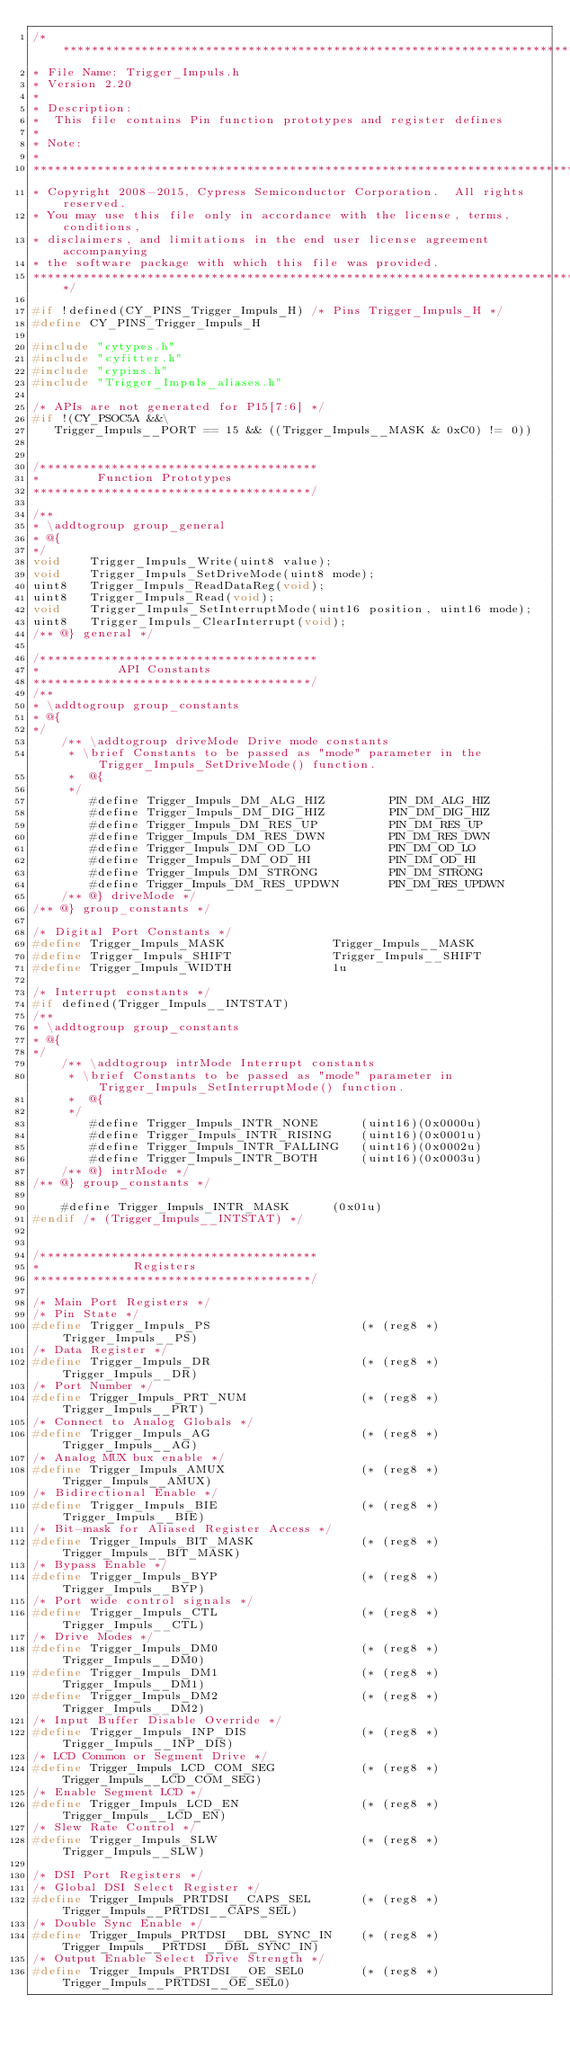<code> <loc_0><loc_0><loc_500><loc_500><_C_>/*******************************************************************************
* File Name: Trigger_Impuls.h  
* Version 2.20
*
* Description:
*  This file contains Pin function prototypes and register defines
*
* Note:
*
********************************************************************************
* Copyright 2008-2015, Cypress Semiconductor Corporation.  All rights reserved.
* You may use this file only in accordance with the license, terms, conditions, 
* disclaimers, and limitations in the end user license agreement accompanying 
* the software package with which this file was provided.
*******************************************************************************/

#if !defined(CY_PINS_Trigger_Impuls_H) /* Pins Trigger_Impuls_H */
#define CY_PINS_Trigger_Impuls_H

#include "cytypes.h"
#include "cyfitter.h"
#include "cypins.h"
#include "Trigger_Impuls_aliases.h"

/* APIs are not generated for P15[7:6] */
#if !(CY_PSOC5A &&\
	 Trigger_Impuls__PORT == 15 && ((Trigger_Impuls__MASK & 0xC0) != 0))


/***************************************
*        Function Prototypes             
***************************************/    

/**
* \addtogroup group_general
* @{
*/
void    Trigger_Impuls_Write(uint8 value);
void    Trigger_Impuls_SetDriveMode(uint8 mode);
uint8   Trigger_Impuls_ReadDataReg(void);
uint8   Trigger_Impuls_Read(void);
void    Trigger_Impuls_SetInterruptMode(uint16 position, uint16 mode);
uint8   Trigger_Impuls_ClearInterrupt(void);
/** @} general */

/***************************************
*           API Constants        
***************************************/
/**
* \addtogroup group_constants
* @{
*/
    /** \addtogroup driveMode Drive mode constants
     * \brief Constants to be passed as "mode" parameter in the Trigger_Impuls_SetDriveMode() function.
     *  @{
     */
        #define Trigger_Impuls_DM_ALG_HIZ         PIN_DM_ALG_HIZ
        #define Trigger_Impuls_DM_DIG_HIZ         PIN_DM_DIG_HIZ
        #define Trigger_Impuls_DM_RES_UP          PIN_DM_RES_UP
        #define Trigger_Impuls_DM_RES_DWN         PIN_DM_RES_DWN
        #define Trigger_Impuls_DM_OD_LO           PIN_DM_OD_LO
        #define Trigger_Impuls_DM_OD_HI           PIN_DM_OD_HI
        #define Trigger_Impuls_DM_STRONG          PIN_DM_STRONG
        #define Trigger_Impuls_DM_RES_UPDWN       PIN_DM_RES_UPDWN
    /** @} driveMode */
/** @} group_constants */
    
/* Digital Port Constants */
#define Trigger_Impuls_MASK               Trigger_Impuls__MASK
#define Trigger_Impuls_SHIFT              Trigger_Impuls__SHIFT
#define Trigger_Impuls_WIDTH              1u

/* Interrupt constants */
#if defined(Trigger_Impuls__INTSTAT)
/**
* \addtogroup group_constants
* @{
*/
    /** \addtogroup intrMode Interrupt constants
     * \brief Constants to be passed as "mode" parameter in Trigger_Impuls_SetInterruptMode() function.
     *  @{
     */
        #define Trigger_Impuls_INTR_NONE      (uint16)(0x0000u)
        #define Trigger_Impuls_INTR_RISING    (uint16)(0x0001u)
        #define Trigger_Impuls_INTR_FALLING   (uint16)(0x0002u)
        #define Trigger_Impuls_INTR_BOTH      (uint16)(0x0003u) 
    /** @} intrMode */
/** @} group_constants */

    #define Trigger_Impuls_INTR_MASK      (0x01u) 
#endif /* (Trigger_Impuls__INTSTAT) */


/***************************************
*             Registers        
***************************************/

/* Main Port Registers */
/* Pin State */
#define Trigger_Impuls_PS                     (* (reg8 *) Trigger_Impuls__PS)
/* Data Register */
#define Trigger_Impuls_DR                     (* (reg8 *) Trigger_Impuls__DR)
/* Port Number */
#define Trigger_Impuls_PRT_NUM                (* (reg8 *) Trigger_Impuls__PRT) 
/* Connect to Analog Globals */                                                  
#define Trigger_Impuls_AG                     (* (reg8 *) Trigger_Impuls__AG)                       
/* Analog MUX bux enable */
#define Trigger_Impuls_AMUX                   (* (reg8 *) Trigger_Impuls__AMUX) 
/* Bidirectional Enable */                                                        
#define Trigger_Impuls_BIE                    (* (reg8 *) Trigger_Impuls__BIE)
/* Bit-mask for Aliased Register Access */
#define Trigger_Impuls_BIT_MASK               (* (reg8 *) Trigger_Impuls__BIT_MASK)
/* Bypass Enable */
#define Trigger_Impuls_BYP                    (* (reg8 *) Trigger_Impuls__BYP)
/* Port wide control signals */                                                   
#define Trigger_Impuls_CTL                    (* (reg8 *) Trigger_Impuls__CTL)
/* Drive Modes */
#define Trigger_Impuls_DM0                    (* (reg8 *) Trigger_Impuls__DM0) 
#define Trigger_Impuls_DM1                    (* (reg8 *) Trigger_Impuls__DM1)
#define Trigger_Impuls_DM2                    (* (reg8 *) Trigger_Impuls__DM2) 
/* Input Buffer Disable Override */
#define Trigger_Impuls_INP_DIS                (* (reg8 *) Trigger_Impuls__INP_DIS)
/* LCD Common or Segment Drive */
#define Trigger_Impuls_LCD_COM_SEG            (* (reg8 *) Trigger_Impuls__LCD_COM_SEG)
/* Enable Segment LCD */
#define Trigger_Impuls_LCD_EN                 (* (reg8 *) Trigger_Impuls__LCD_EN)
/* Slew Rate Control */
#define Trigger_Impuls_SLW                    (* (reg8 *) Trigger_Impuls__SLW)

/* DSI Port Registers */
/* Global DSI Select Register */
#define Trigger_Impuls_PRTDSI__CAPS_SEL       (* (reg8 *) Trigger_Impuls__PRTDSI__CAPS_SEL) 
/* Double Sync Enable */
#define Trigger_Impuls_PRTDSI__DBL_SYNC_IN    (* (reg8 *) Trigger_Impuls__PRTDSI__DBL_SYNC_IN) 
/* Output Enable Select Drive Strength */
#define Trigger_Impuls_PRTDSI__OE_SEL0        (* (reg8 *) Trigger_Impuls__PRTDSI__OE_SEL0) </code> 